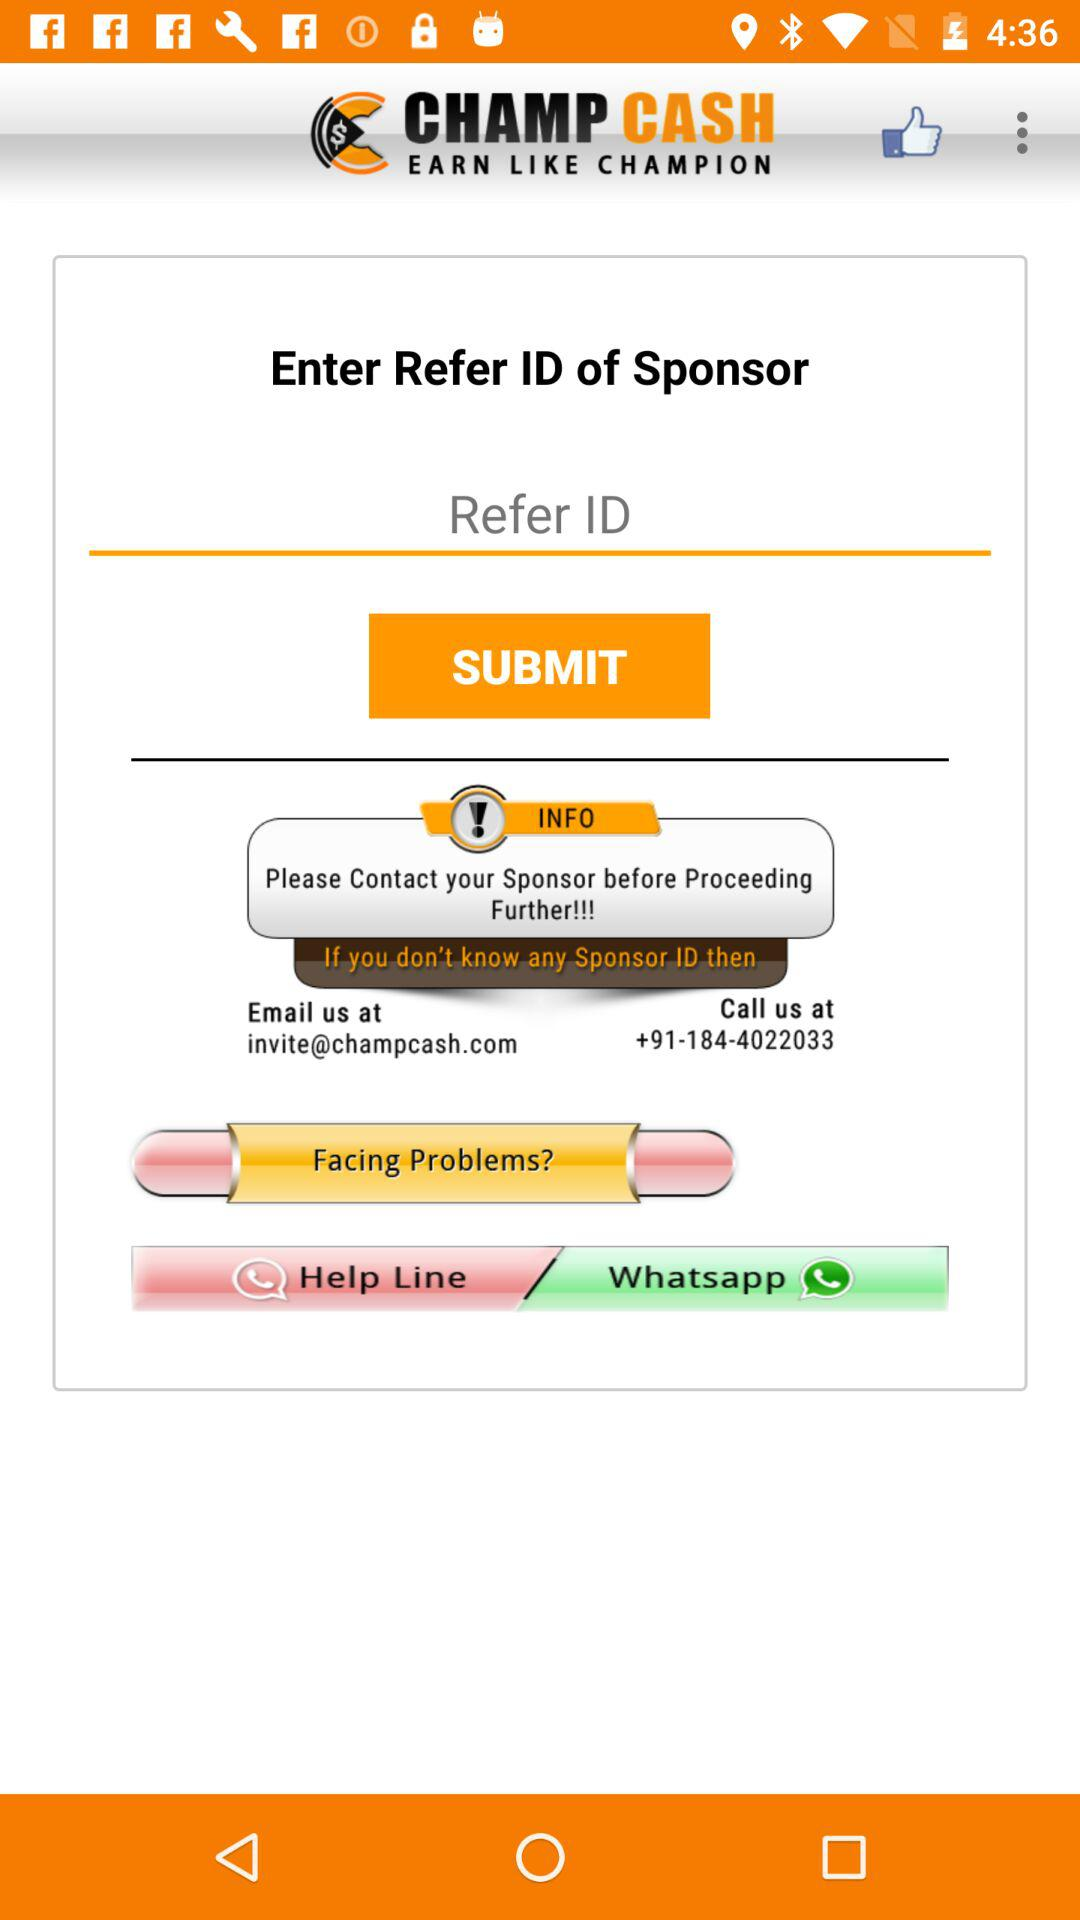How many warning signs are there on this screen?
Answer the question using a single word or phrase. 1 